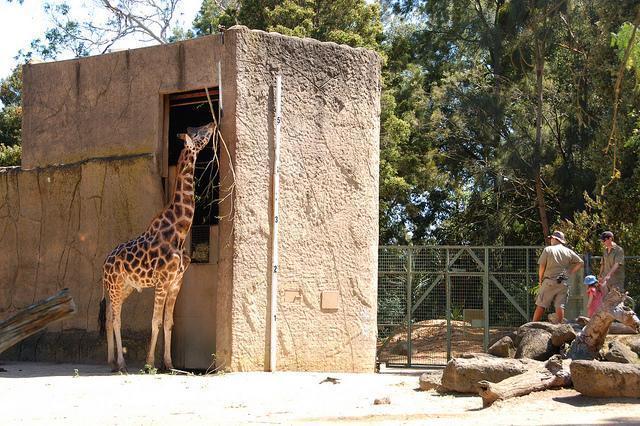How many people are in the picture?
Give a very brief answer. 3. 